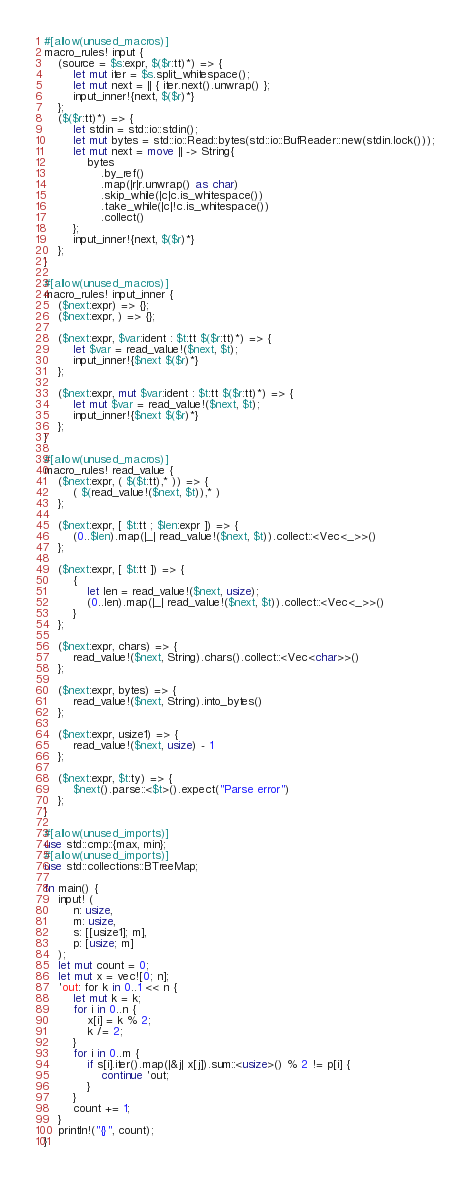<code> <loc_0><loc_0><loc_500><loc_500><_Rust_>#[allow(unused_macros)]
macro_rules! input {
    (source = $s:expr, $($r:tt)*) => {
        let mut iter = $s.split_whitespace();
        let mut next = || { iter.next().unwrap() };
        input_inner!{next, $($r)*}
    };
    ($($r:tt)*) => {
        let stdin = std::io::stdin();
        let mut bytes = std::io::Read::bytes(std::io::BufReader::new(stdin.lock()));
        let mut next = move || -> String{
            bytes
                .by_ref()
                .map(|r|r.unwrap() as char)
                .skip_while(|c|c.is_whitespace())
                .take_while(|c|!c.is_whitespace())
                .collect()
        };
        input_inner!{next, $($r)*}
    };
}

#[allow(unused_macros)]
macro_rules! input_inner {
    ($next:expr) => {};
    ($next:expr, ) => {};

    ($next:expr, $var:ident : $t:tt $($r:tt)*) => {
        let $var = read_value!($next, $t);
        input_inner!{$next $($r)*}
    };

    ($next:expr, mut $var:ident : $t:tt $($r:tt)*) => {
        let mut $var = read_value!($next, $t);
        input_inner!{$next $($r)*}
    };
}

#[allow(unused_macros)]
macro_rules! read_value {
    ($next:expr, ( $($t:tt),* )) => {
        ( $(read_value!($next, $t)),* )
    };

    ($next:expr, [ $t:tt ; $len:expr ]) => {
        (0..$len).map(|_| read_value!($next, $t)).collect::<Vec<_>>()
    };

    ($next:expr, [ $t:tt ]) => {
        {
            let len = read_value!($next, usize);
            (0..len).map(|_| read_value!($next, $t)).collect::<Vec<_>>()
        }
    };

    ($next:expr, chars) => {
        read_value!($next, String).chars().collect::<Vec<char>>()
    };

    ($next:expr, bytes) => {
        read_value!($next, String).into_bytes()
    };

    ($next:expr, usize1) => {
        read_value!($next, usize) - 1
    };

    ($next:expr, $t:ty) => {
        $next().parse::<$t>().expect("Parse error")
    };
}

#[allow(unused_imports)]
use std::cmp::{max, min};
#[allow(unused_imports)]
use std::collections::BTreeMap;

fn main() {
    input! (
        n: usize,
        m: usize,
        s: [[usize1]; m],
        p: [usize; m]
    );
    let mut count = 0;
    let mut x = vec![0; n];
    'out: for k in 0..1 << n {
        let mut k = k;
        for i in 0..n {
            x[i] = k % 2;
            k /= 2;
        }
        for i in 0..m {
            if s[i].iter().map(|&j| x[j]).sum::<usize>() % 2 != p[i] {
                continue 'out;
            }
        }
        count += 1;
    }
    println!("{}", count);
}
</code> 